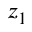Convert formula to latex. <formula><loc_0><loc_0><loc_500><loc_500>z _ { 1 }</formula> 